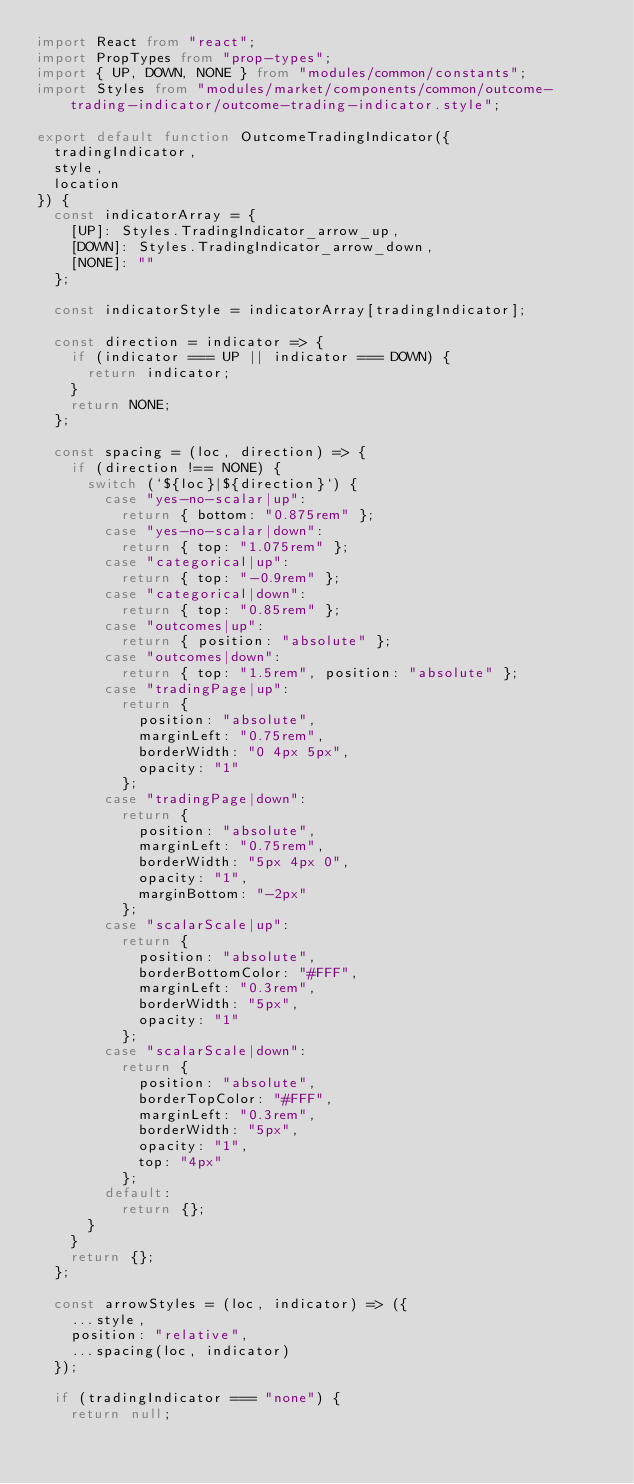Convert code to text. <code><loc_0><loc_0><loc_500><loc_500><_TypeScript_>import React from "react";
import PropTypes from "prop-types";
import { UP, DOWN, NONE } from "modules/common/constants";
import Styles from "modules/market/components/common/outcome-trading-indicator/outcome-trading-indicator.style";

export default function OutcomeTradingIndicator({
  tradingIndicator,
  style,
  location
}) {
  const indicatorArray = {
    [UP]: Styles.TradingIndicator_arrow_up,
    [DOWN]: Styles.TradingIndicator_arrow_down,
    [NONE]: ""
  };

  const indicatorStyle = indicatorArray[tradingIndicator];

  const direction = indicator => {
    if (indicator === UP || indicator === DOWN) {
      return indicator;
    }
    return NONE;
  };

  const spacing = (loc, direction) => {
    if (direction !== NONE) {
      switch (`${loc}|${direction}`) {
        case "yes-no-scalar|up":
          return { bottom: "0.875rem" };
        case "yes-no-scalar|down":
          return { top: "1.075rem" };
        case "categorical|up":
          return { top: "-0.9rem" };
        case "categorical|down":
          return { top: "0.85rem" };
        case "outcomes|up":
          return { position: "absolute" };
        case "outcomes|down":
          return { top: "1.5rem", position: "absolute" };
        case "tradingPage|up":
          return {
            position: "absolute",
            marginLeft: "0.75rem",
            borderWidth: "0 4px 5px",
            opacity: "1"
          };
        case "tradingPage|down":
          return {
            position: "absolute",
            marginLeft: "0.75rem",
            borderWidth: "5px 4px 0",
            opacity: "1",
            marginBottom: "-2px"
          };
        case "scalarScale|up":
          return {
            position: "absolute",
            borderBottomColor: "#FFF",
            marginLeft: "0.3rem",
            borderWidth: "5px",
            opacity: "1"
          };
        case "scalarScale|down":
          return {
            position: "absolute",
            borderTopColor: "#FFF",
            marginLeft: "0.3rem",
            borderWidth: "5px",
            opacity: "1",
            top: "4px"
          };
        default:
          return {};
      }
    }
    return {};
  };

  const arrowStyles = (loc, indicator) => ({
    ...style,
    position: "relative",
    ...spacing(loc, indicator)
  });

  if (tradingIndicator === "none") {
    return null;</code> 